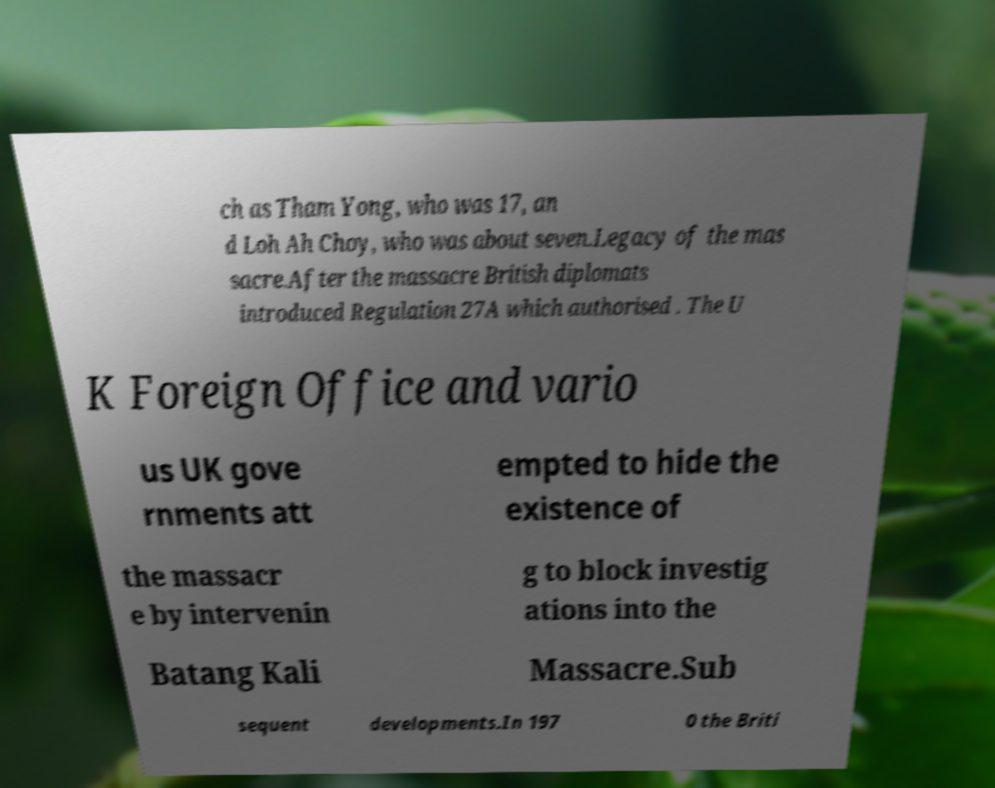Please identify and transcribe the text found in this image. ch as Tham Yong, who was 17, an d Loh Ah Choy, who was about seven.Legacy of the mas sacre.After the massacre British diplomats introduced Regulation 27A which authorised . The U K Foreign Office and vario us UK gove rnments att empted to hide the existence of the massacr e by intervenin g to block investig ations into the Batang Kali Massacre.Sub sequent developments.In 197 0 the Briti 